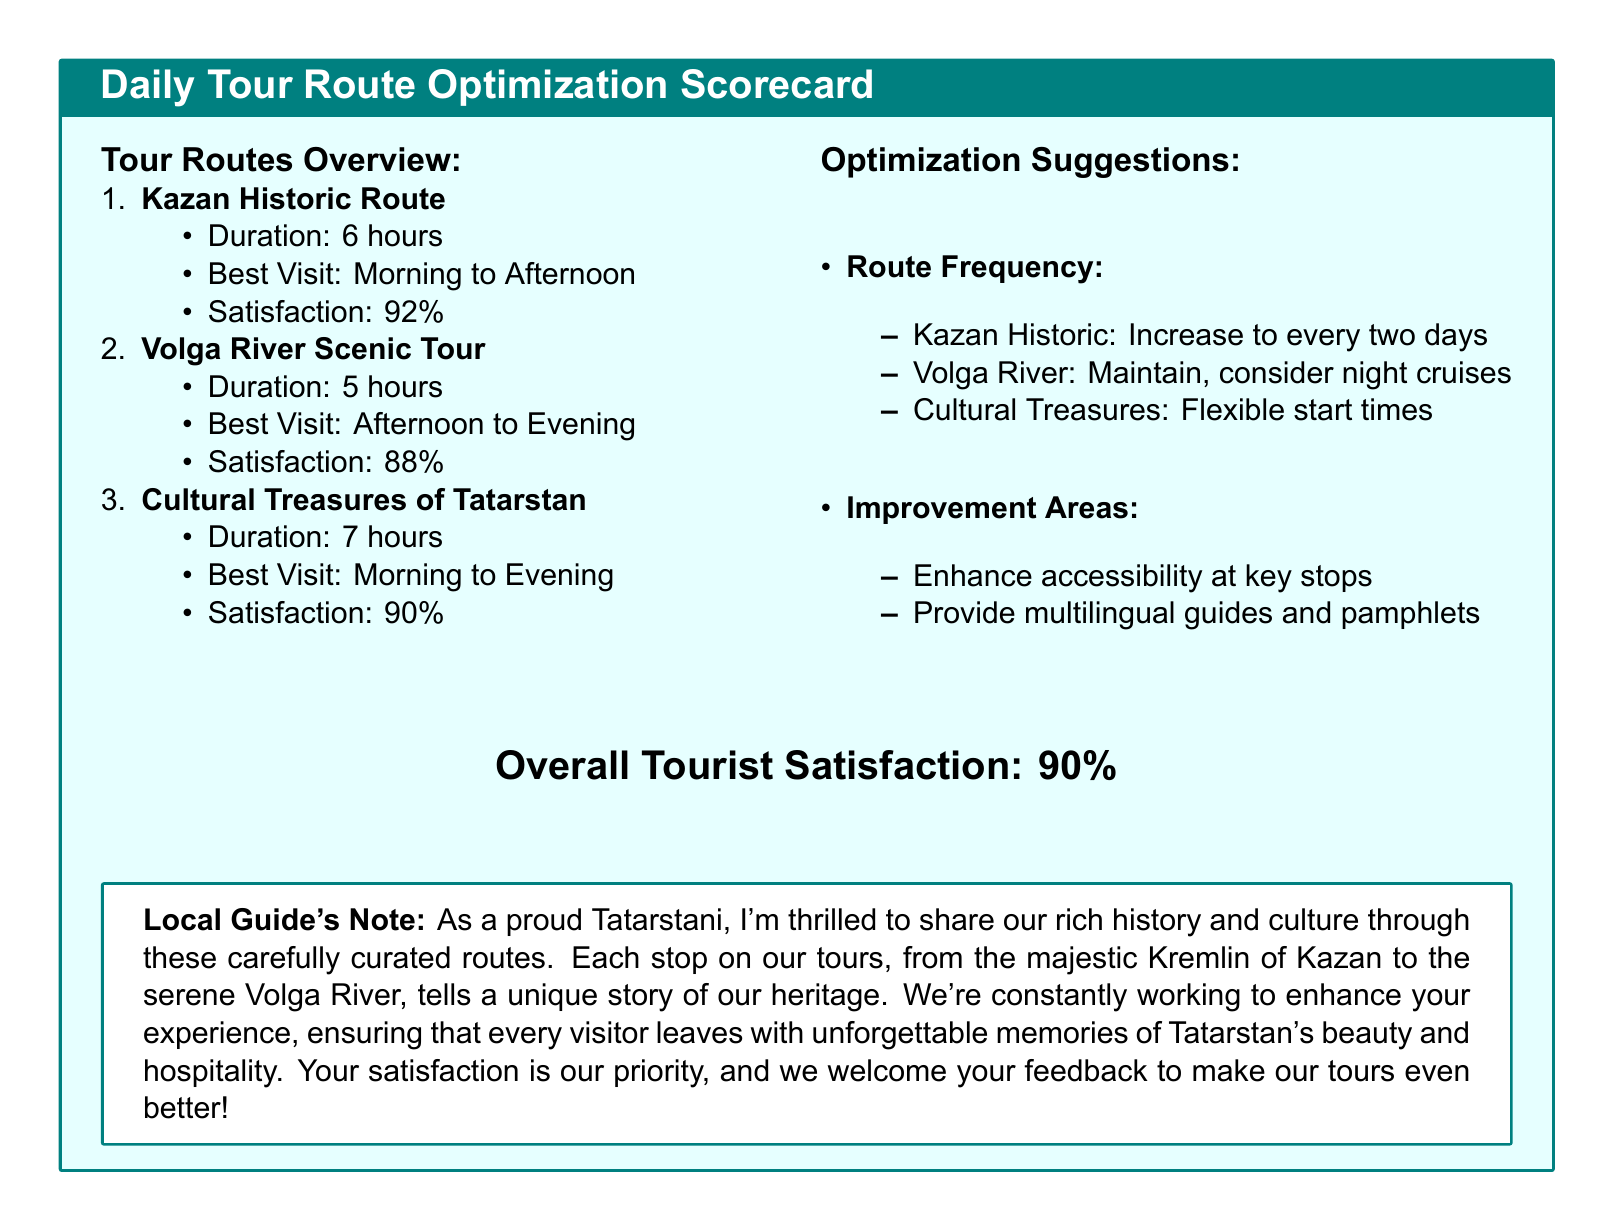What is the duration of the Kazan Historic Route? The duration of the Kazan Historic Route is specified in the document as 6 hours.
Answer: 6 hours What is the tourist satisfaction percentage for the Volga River Scenic Tour? The document states that the satisfaction percentage for the Volga River Scenic Tour is 88%.
Answer: 88% When is the best time to visit the Cultural Treasures of Tatarstan? The best visit time for the Cultural Treasures of Tatarstan is from Morning to Evening, as mentioned in the scorecard.
Answer: Morning to Evening What are the recommended changes for the frequency of the Kazan Historic Route? The document suggests increasing the frequency of the Kazan Historic Route to every two days.
Answer: Every two days What is the overall tourist satisfaction percentage reported in the document? The overall satisfaction percentage is listed in the document as 90%.
Answer: 90% How long is the Volga River Scenic Tour? The duration of the Volga River Scenic Tour is given as 5 hours.
Answer: 5 hours What improvement area is highlighted for the tours? The document emphasizes enhancing accessibility at key stops as an improvement area for the tours.
Answer: Accessibility at key stops What suggestion is made for the Volga River tour? The document mentions considering night cruises as a suggestion for the Volga River tour.
Answer: Night cruises Why does the local guide mention visitor feedback? The local guide mentions feedback as a way to make tours better, ensuring that every visitor has a memorable experience.
Answer: To make tours better 